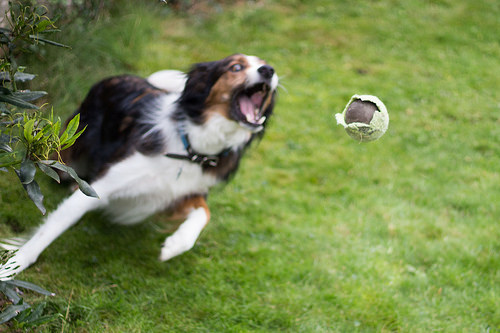<image>
Is there a ball to the right of the dog? Yes. From this viewpoint, the ball is positioned to the right side relative to the dog. Where is the dog in relation to the grass? Is it on the grass? Yes. Looking at the image, I can see the dog is positioned on top of the grass, with the grass providing support. Is there a dog behind the ball? Yes. From this viewpoint, the dog is positioned behind the ball, with the ball partially or fully occluding the dog. Where is the ball in relation to the grass? Is it above the grass? Yes. The ball is positioned above the grass in the vertical space, higher up in the scene. 